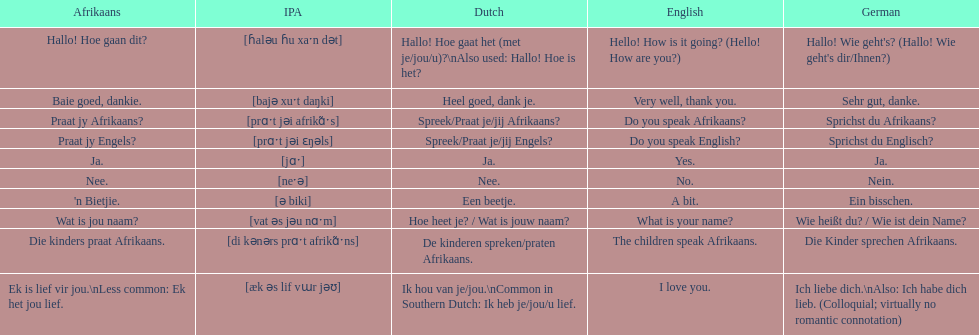What are all of the afrikaans phrases in the list? Hallo! Hoe gaan dit?, Baie goed, dankie., Praat jy Afrikaans?, Praat jy Engels?, Ja., Nee., 'n Bietjie., Wat is jou naam?, Die kinders praat Afrikaans., Ek is lief vir jou.\nLess common: Ek het jou lief. What is the english translation of each phrase? Hello! How is it going? (Hello! How are you?), Very well, thank you., Do you speak Afrikaans?, Do you speak English?, Yes., No., A bit., What is your name?, The children speak Afrikaans., I love you. And which afrikaans phrase translated to do you speak afrikaans? Praat jy Afrikaans?. 